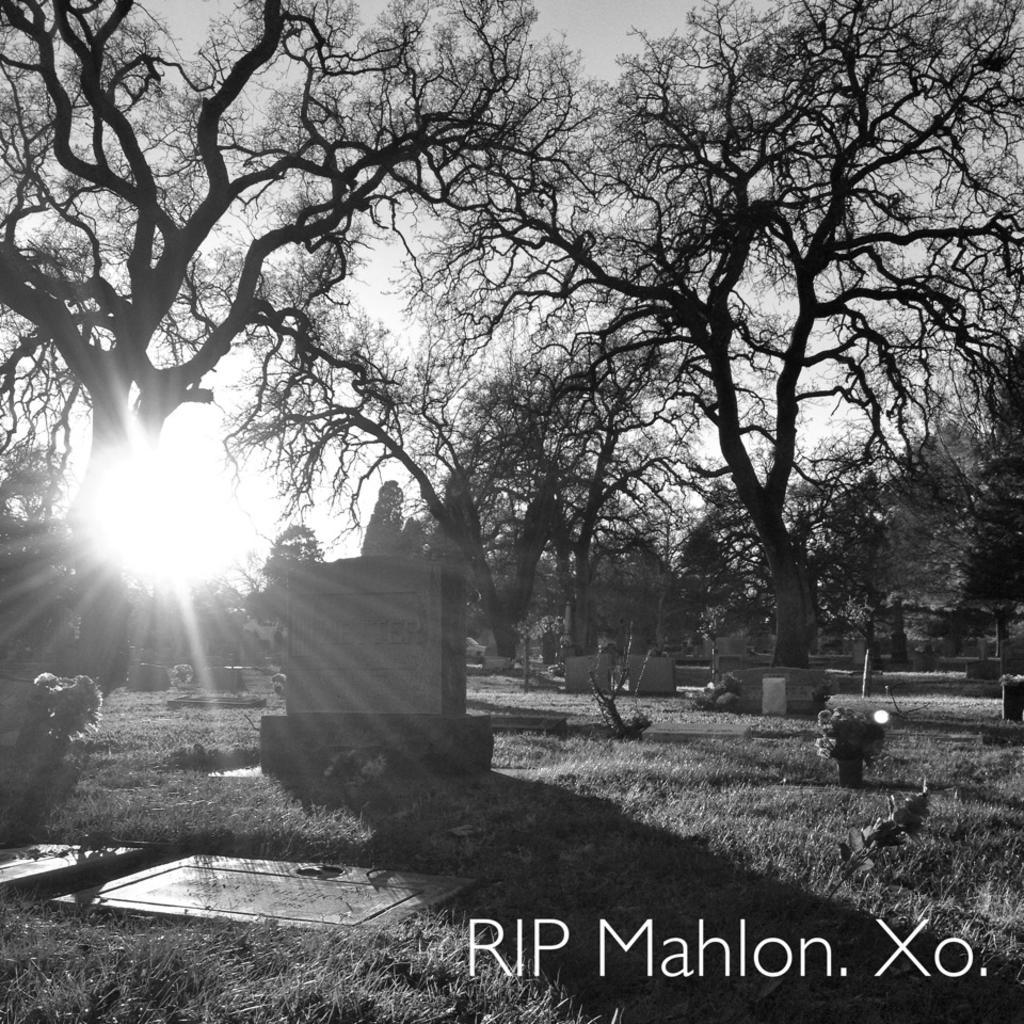How would you summarize this image in a sentence or two? This is black and white picture of a graveyard where we can see trees, grassy land and sun. 